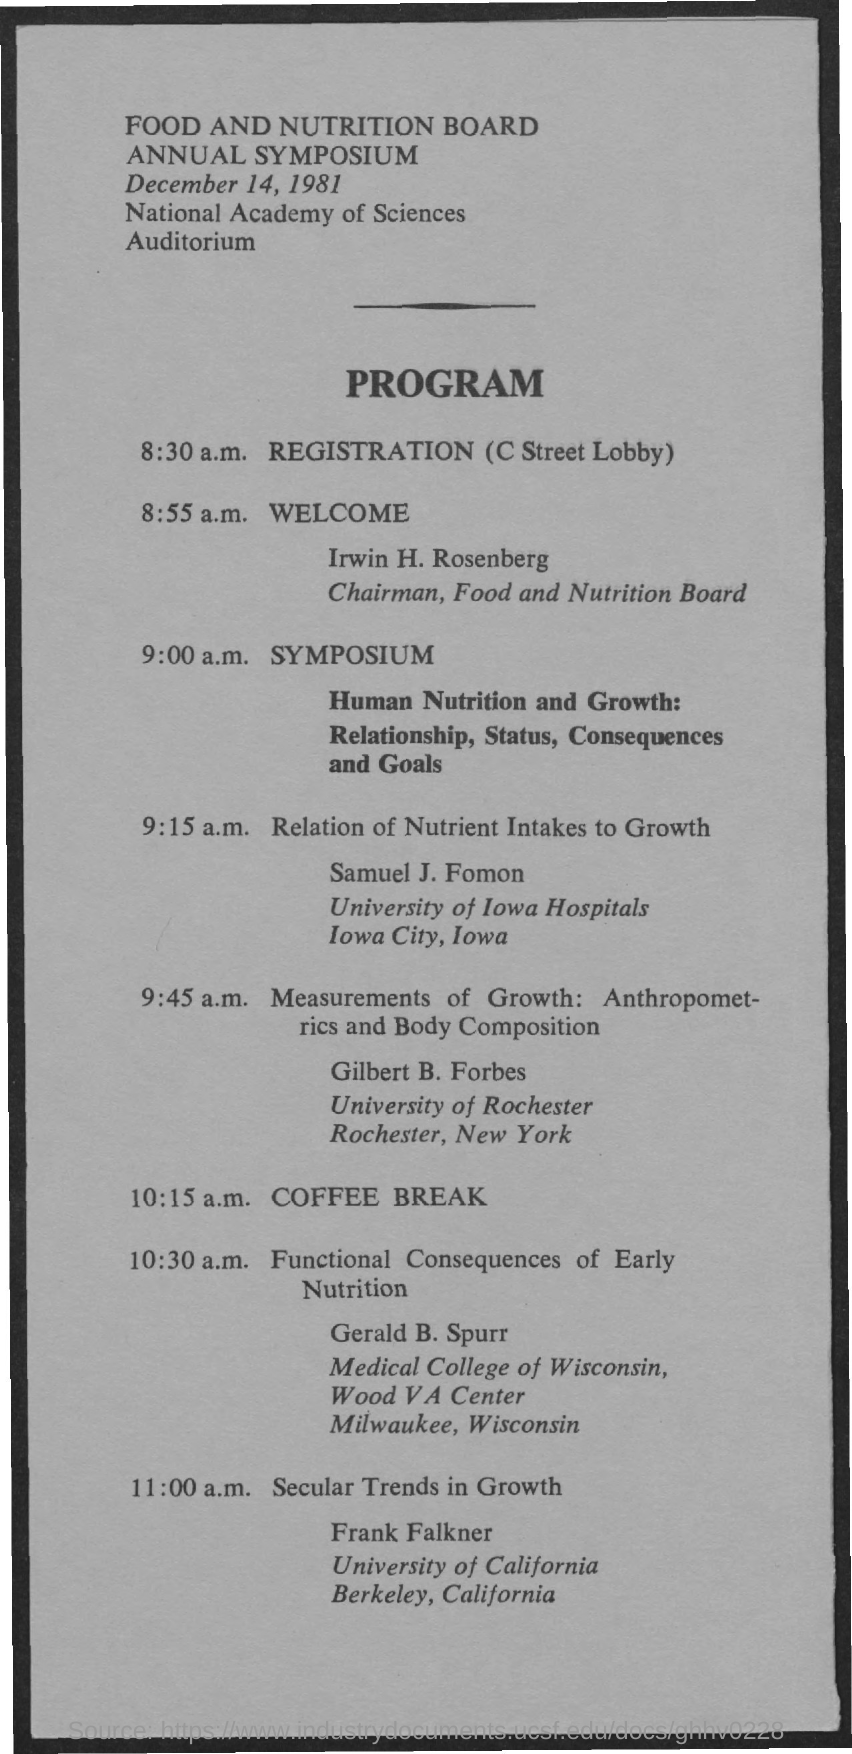When is annual symposium held at?
Provide a short and direct response. December 14, 1981. Who is the chairman of food and nutrition board?
Your response must be concise. Irwin H. Rosenberg. Who is representing university of iowa hospitals iowa city, iowa?
Provide a succinct answer. Samuel J. Fomon. Who is representing university of rochester, rochester, new york?
Make the answer very short. Gilbert B. Forbes. Who is representing University of California Berkeley, California?
Your answer should be very brief. Frank Falkner. Who is representing medical college of wisconsin, wood v a center, milwaukee,wisconsin?
Offer a terse response. Gerald B. Spurr. 